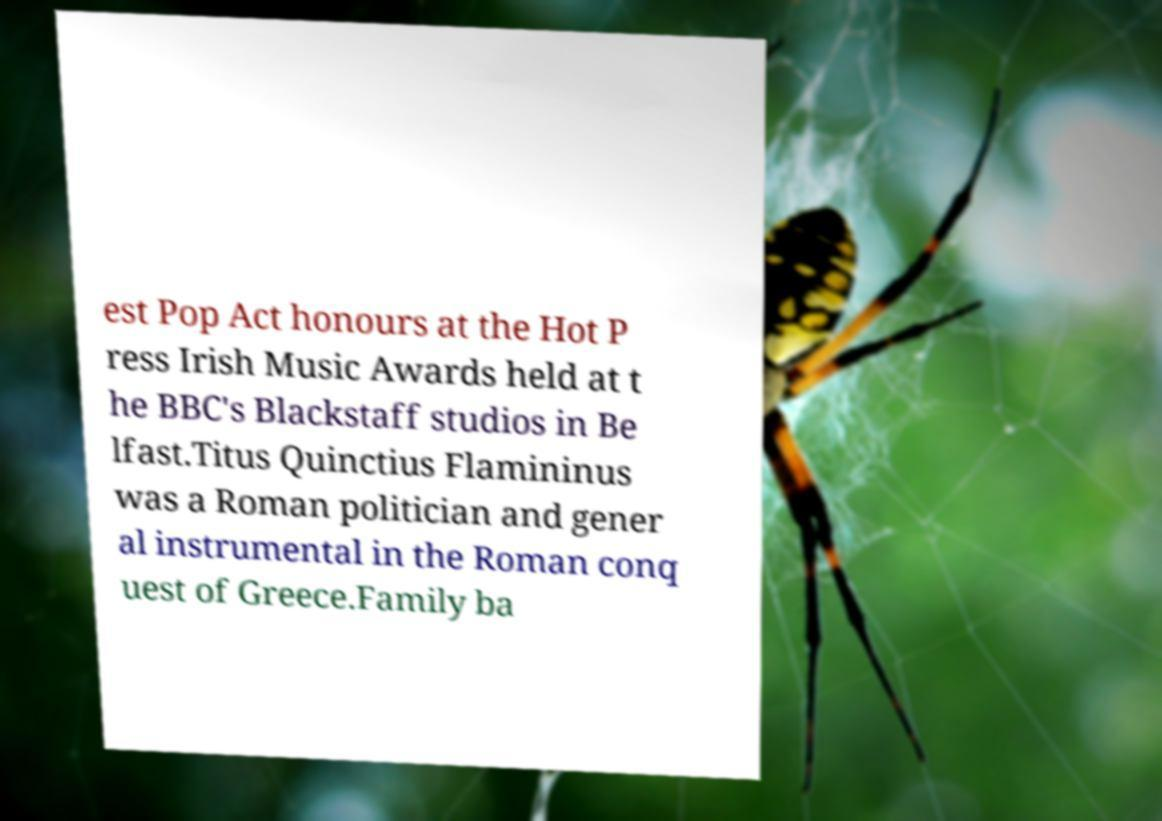There's text embedded in this image that I need extracted. Can you transcribe it verbatim? est Pop Act honours at the Hot P ress Irish Music Awards held at t he BBC's Blackstaff studios in Be lfast.Titus Quinctius Flamininus was a Roman politician and gener al instrumental in the Roman conq uest of Greece.Family ba 